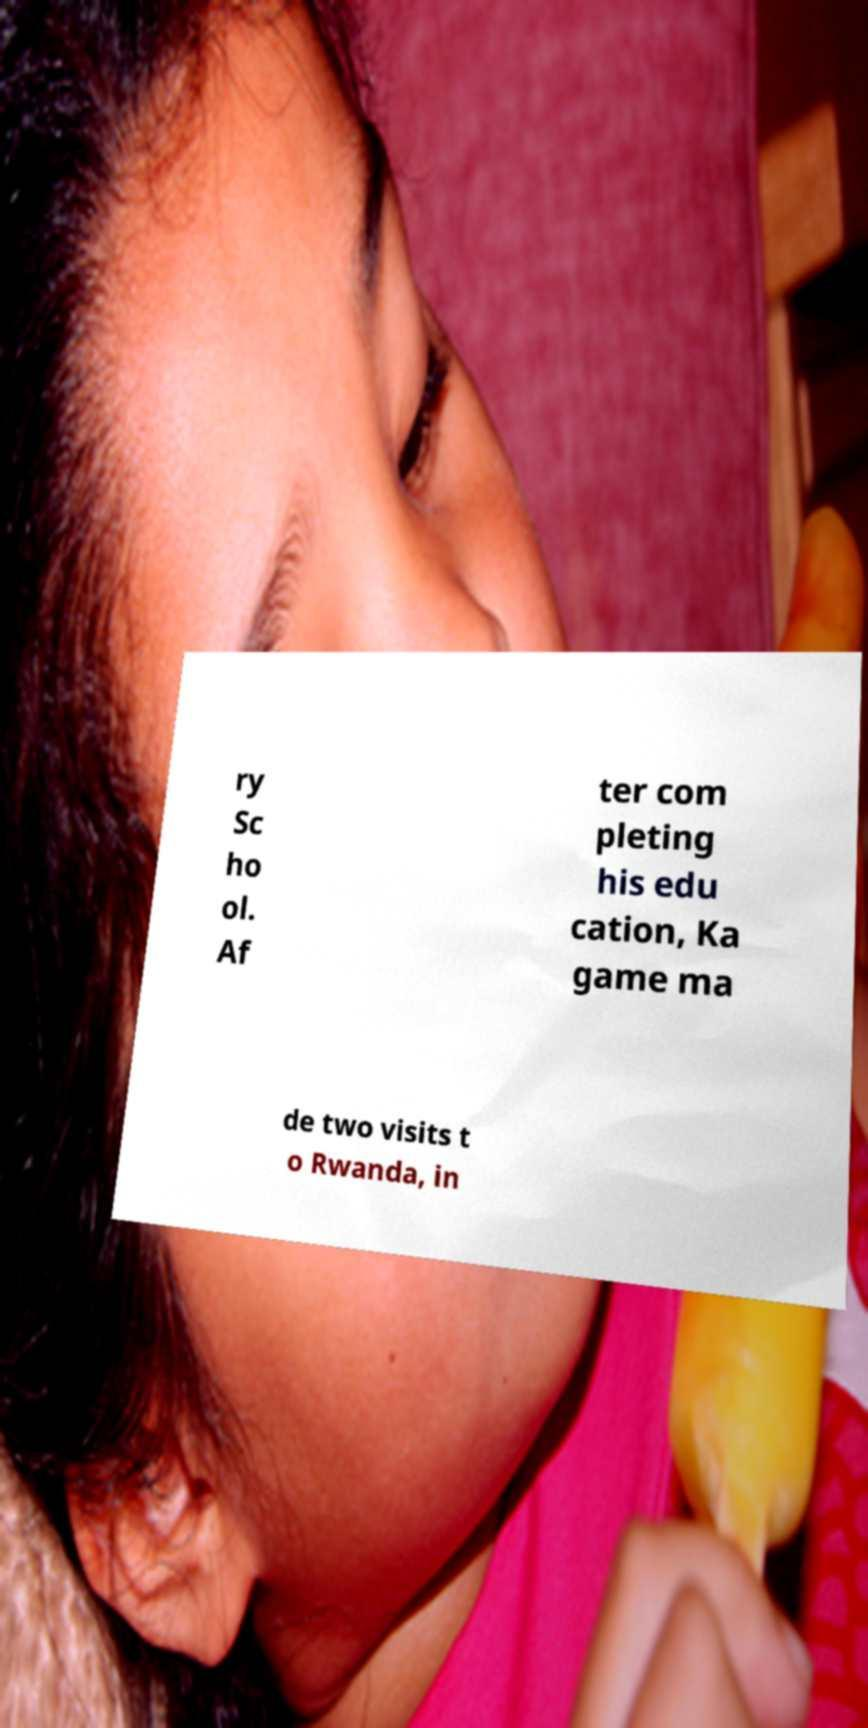For documentation purposes, I need the text within this image transcribed. Could you provide that? ry Sc ho ol. Af ter com pleting his edu cation, Ka game ma de two visits t o Rwanda, in 